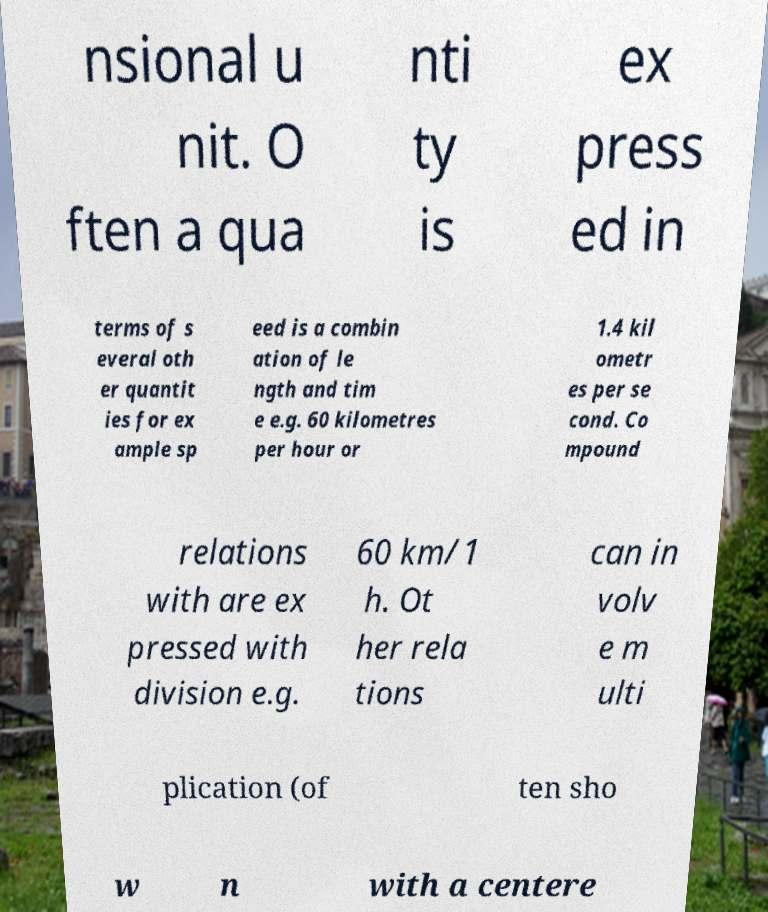What messages or text are displayed in this image? I need them in a readable, typed format. nsional u nit. O ften a qua nti ty is ex press ed in terms of s everal oth er quantit ies for ex ample sp eed is a combin ation of le ngth and tim e e.g. 60 kilometres per hour or 1.4 kil ometr es per se cond. Co mpound relations with are ex pressed with division e.g. 60 km/1 h. Ot her rela tions can in volv e m ulti plication (of ten sho w n with a centere 